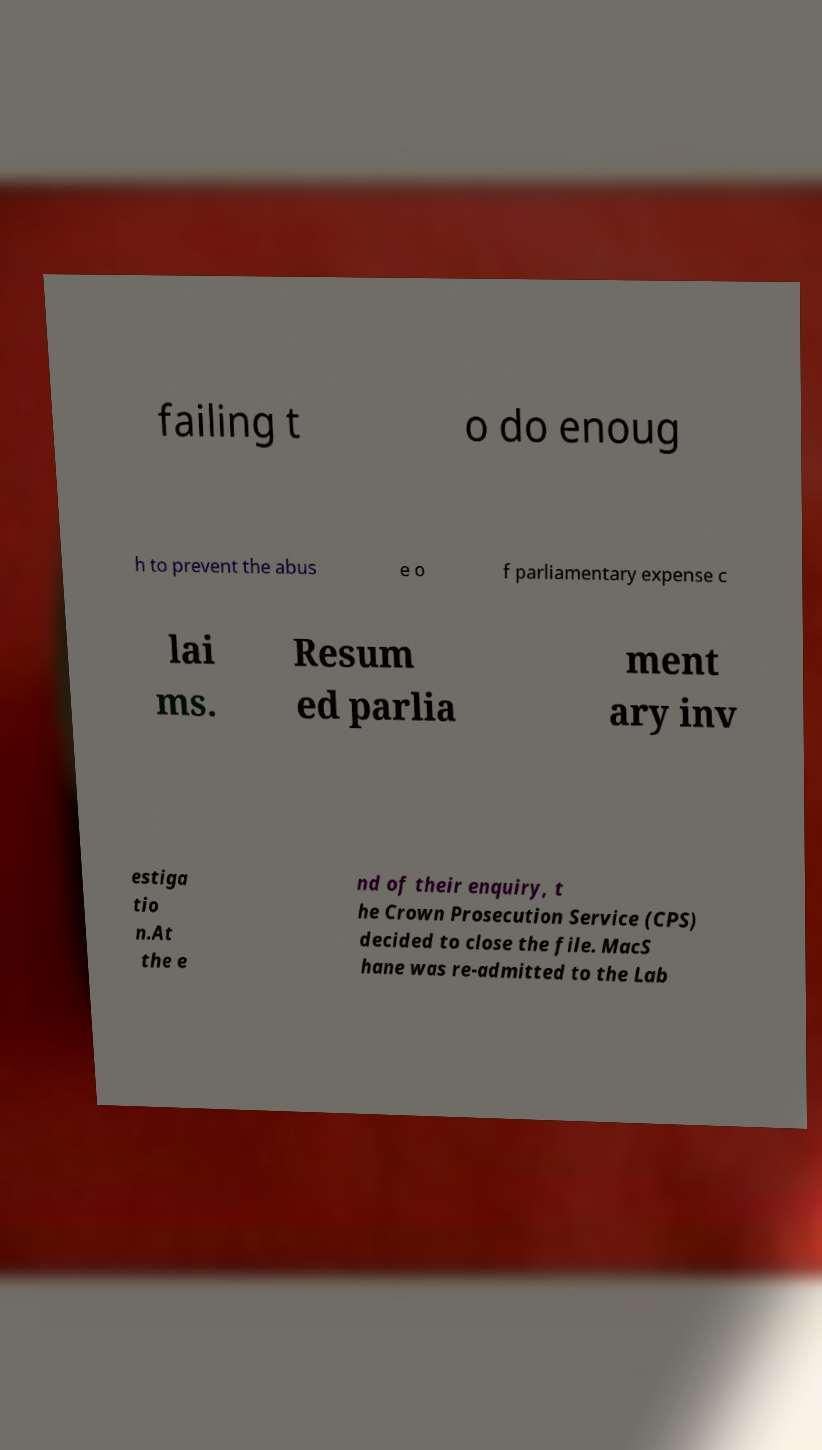I need the written content from this picture converted into text. Can you do that? failing t o do enoug h to prevent the abus e o f parliamentary expense c lai ms. Resum ed parlia ment ary inv estiga tio n.At the e nd of their enquiry, t he Crown Prosecution Service (CPS) decided to close the file. MacS hane was re-admitted to the Lab 